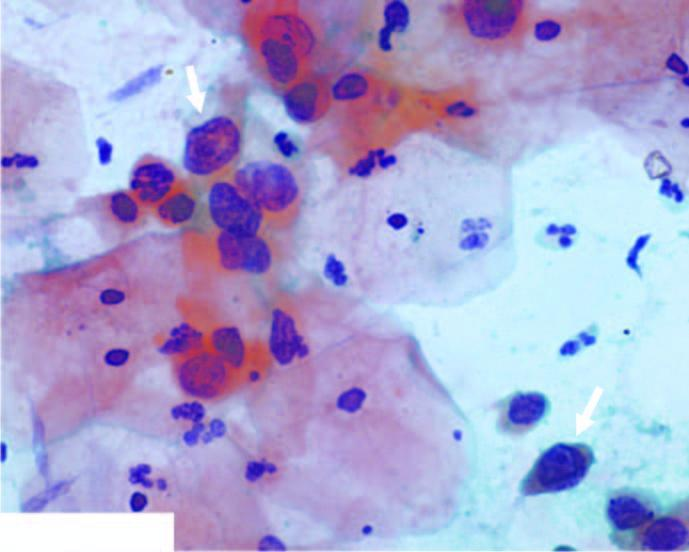does replication of viral dna show numerous pmns?
Answer the question using a single word or phrase. No 